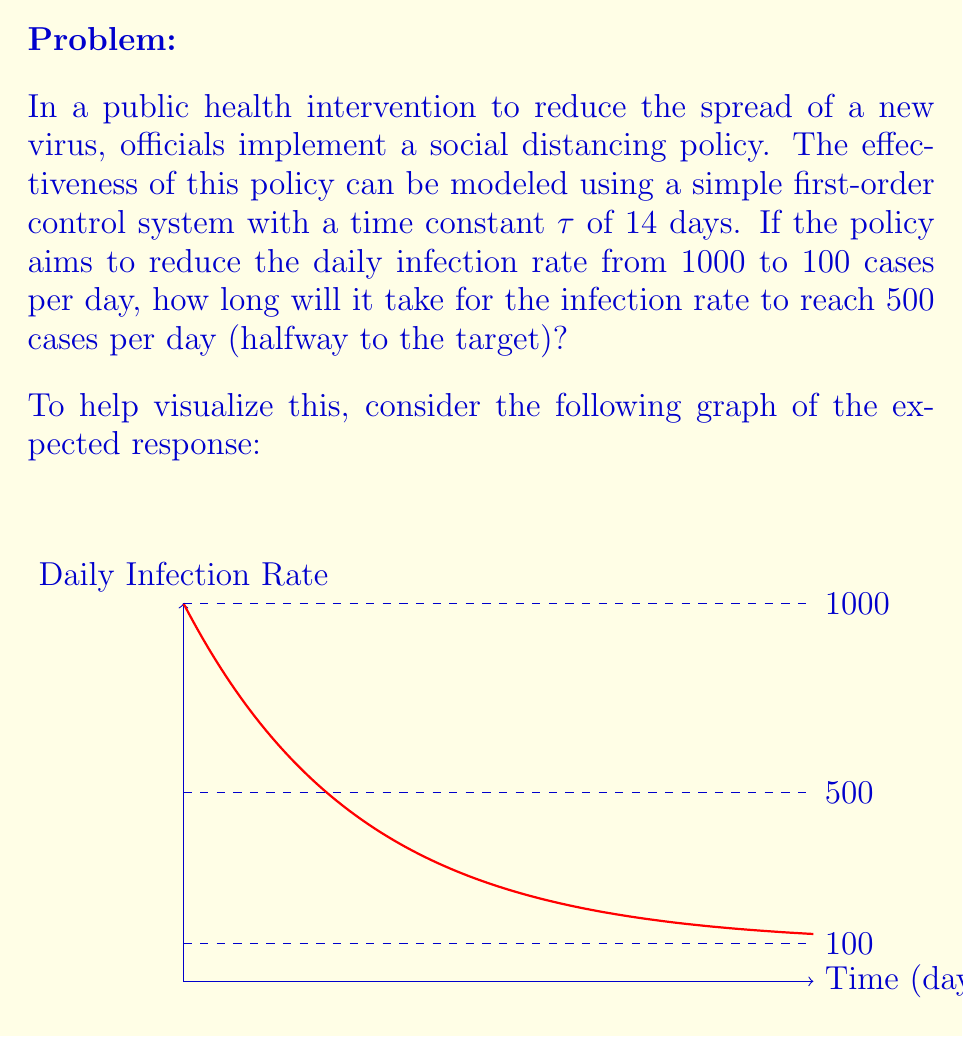Show me your answer to this math problem. To solve this problem, we'll use the principles of control theory applied to a first-order system. The steps are as follows:

1) The general equation for a first-order system response is:

   $$y(t) = y_f + (y_i - y_f)e^{-t/\tau}$$

   Where:
   $y(t)$ is the output at time $t$
   $y_f$ is the final steady-state value
   $y_i$ is the initial value
   $\tau$ is the time constant

2) In our case:
   $y_i = 1000$ (initial infection rate)
   $y_f = 100$ (target infection rate)
   $\tau = 14$ days

3) We want to find $t$ when $y(t) = 500$ (halfway to the target)

4) Substituting these values into the equation:

   $$500 = 100 + (1000 - 100)e^{-t/14}$$

5) Simplify:
   $$500 = 100 + 900e^{-t/14}$$

6) Subtract 100 from both sides:
   $$400 = 900e^{-t/14}$$

7) Divide both sides by 900:
   $$\frac{4}{9} = e^{-t/14}$$

8) Take the natural log of both sides:
   $$\ln(\frac{4}{9}) = -\frac{t}{14}$$

9) Multiply both sides by -14:
   $$-14\ln(\frac{4}{9}) = t$$

10) Calculate the result:
    $$t \approx 9.7$$

Therefore, it will take approximately 9.7 days for the infection rate to reach 500 cases per day.
Answer: 9.7 days 